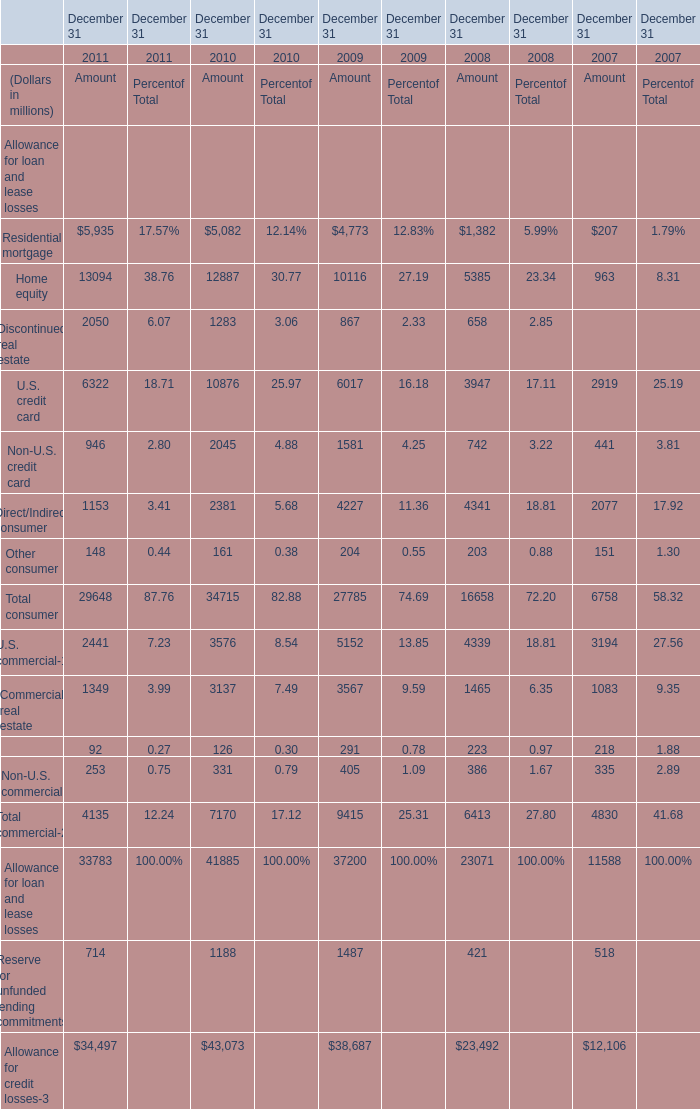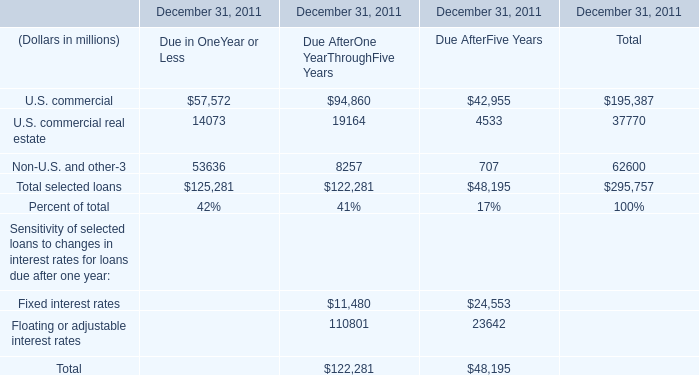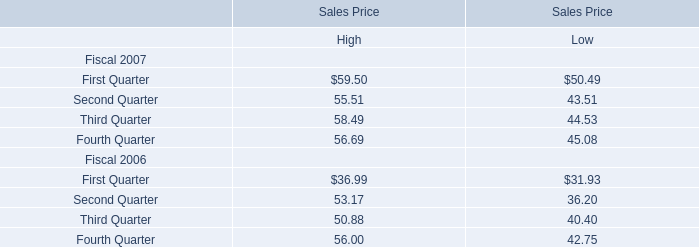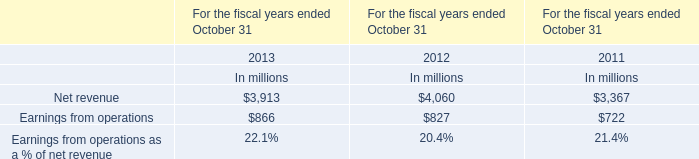What is the total amount of U.S. commercial of December 31, 2011 Due AfterOne YearThroughFive Years, and Reserve for unfunded lending commitments of December 31 2010 Amount ? 
Computations: (94860.0 + 1188.0)
Answer: 96048.0. 